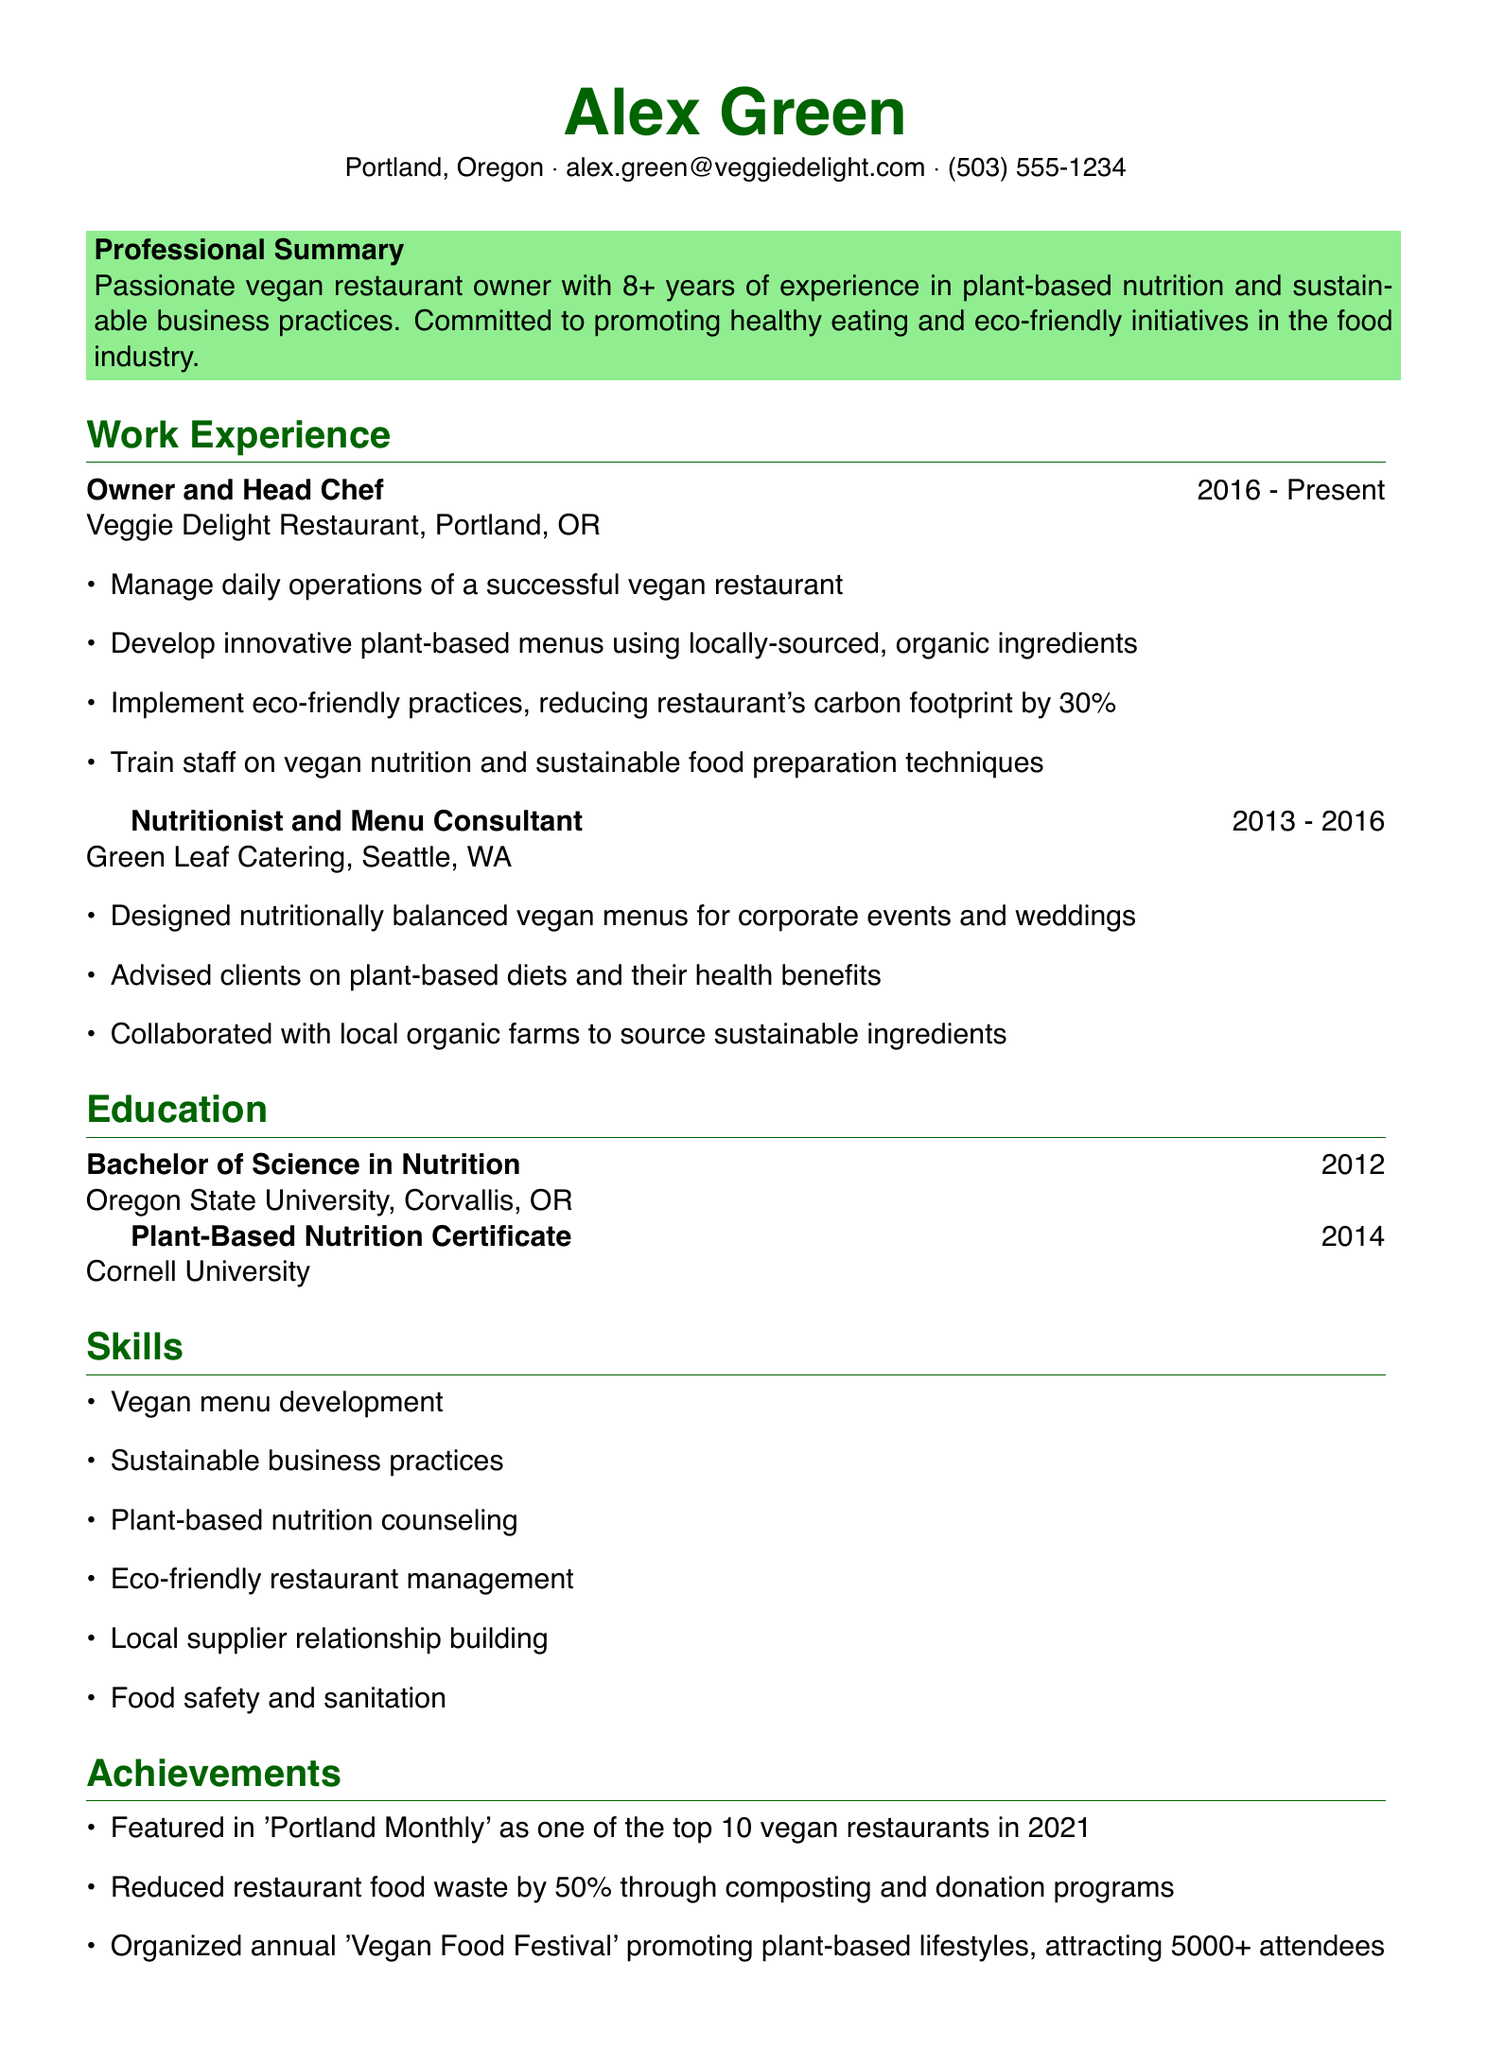What is the name of the restaurant owned by Alex Green? The document lists "Veggie Delight Restaurant" as the establishment owned by Alex Green.
Answer: Veggie Delight Restaurant In which year did Alex Green graduate from Oregon State University? The graduation year listed under education for Oregon State University is 2012.
Answer: 2012 How many years of experience does Alex Green have in the field? The professional summary indicates over 8 years of experience.
Answer: 8+ What percentage did Alex reduce the restaurant's carbon footprint? The document states a reduction of the carbon footprint by 30%.
Answer: 30% What certification did Alex Green obtain from Cornell University? The document specifies a "Plant-Based Nutrition Certificate" was earned from Cornell University.
Answer: Plant-Based Nutrition Certificate During which years did Alex work as a Nutritionist and Menu Consultant? The work experience section shows this position was held from 2013 to 2016.
Answer: 2013 - 2016 What is one of the skills mentioned in the skills section? The skills section lists "Sustainable business practices" as one of the skills.
Answer: Sustainable business practices What notable recognition did the restaurant receive in 2021? The achievements highlight being featured in 'Portland Monthly' as a top vegan restaurant in 2021.
Answer: Top 10 vegan restaurants in 2021 How much did Alex reduce restaurant food waste? The document states that food waste was reduced by 50% through specific initiatives.
Answer: 50% 